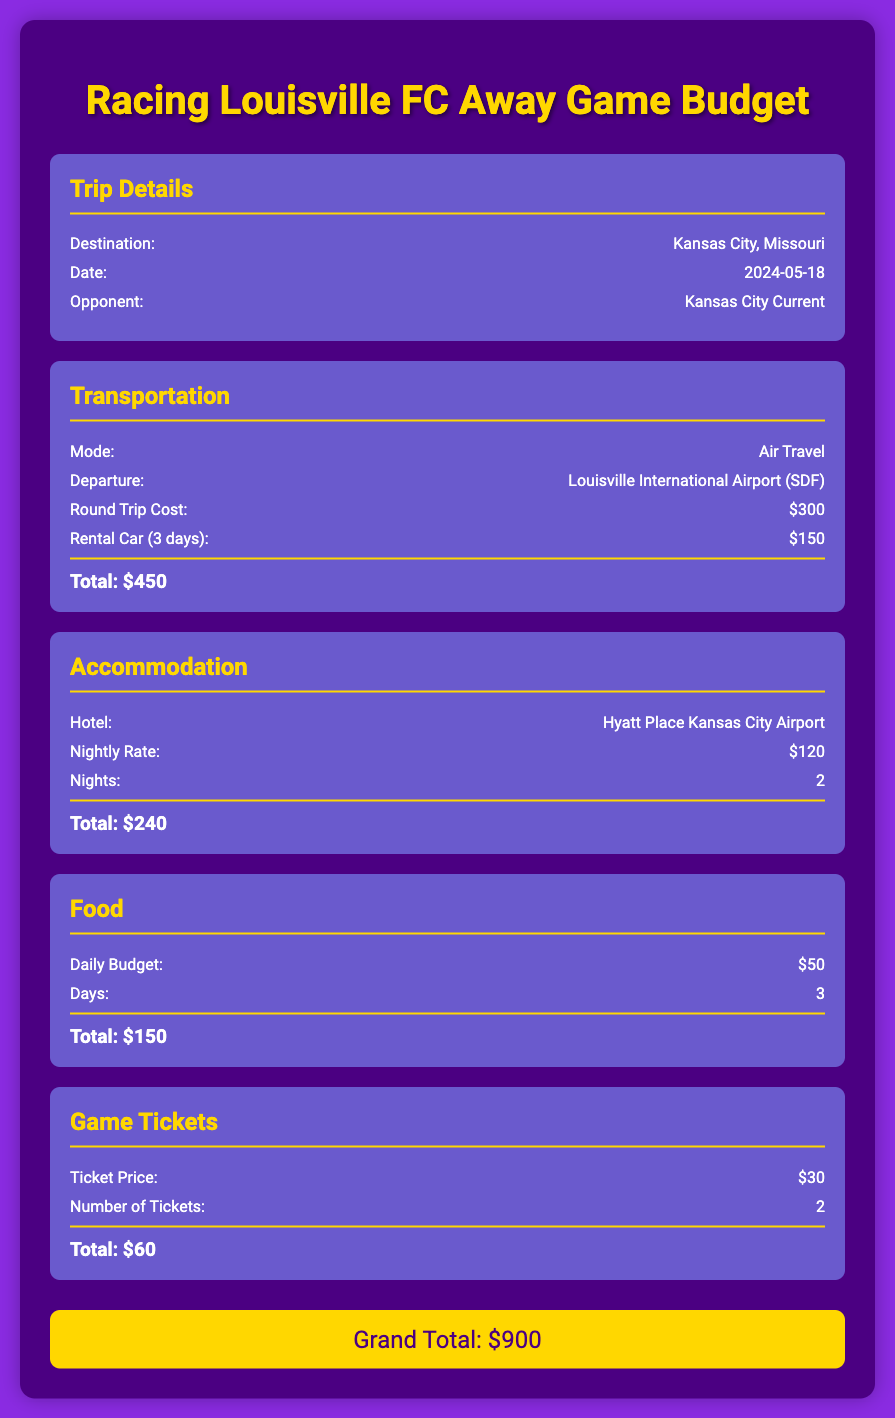What is the destination for the away game? The document specifies that the destination for the away game is Kansas City, Missouri.
Answer: Kansas City, Missouri What is the date of the trip? The date mentioned in the document for the trip is 2024-05-18.
Answer: 2024-05-18 What is the total cost for transportation? The total cost for transportation, which includes air travel and a rental car, is calculated to be $450.
Answer: $450 How much is the nightly rate for the hotel? The document states that the nightly rate for the hotel is $120.
Answer: $120 What is the total cost for food? The total cost for food is calculated based on the daily budget and days spent, resulting in a total of $150.
Answer: $150 What is the total amount spent on game tickets? The total amount spent on game tickets is $60, calculated from the ticket price and number of tickets.
Answer: $60 How many nights will the team stay at the hotel? The document indicates that the team will stay for 2 nights at the hotel.
Answer: 2 What is the grand total for the entire trip? The grand total for all expenses related to the trip is $900, as stated in the document.
Answer: $900 What transportation mode is used? The document specifies that the mode of transportation used is air travel.
Answer: Air Travel 